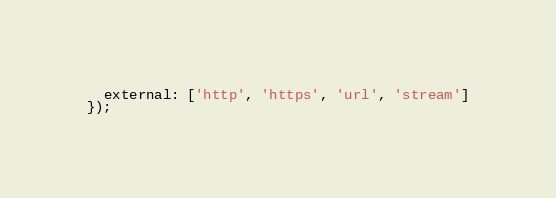<code> <loc_0><loc_0><loc_500><loc_500><_JavaScript_>  external: ['http', 'https', 'url', 'stream']
});
</code> 